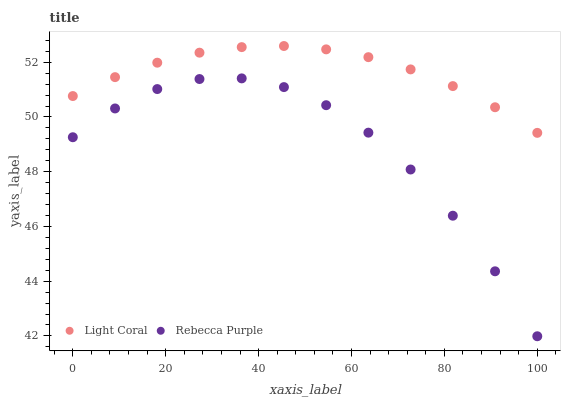Does Rebecca Purple have the minimum area under the curve?
Answer yes or no. Yes. Does Light Coral have the maximum area under the curve?
Answer yes or no. Yes. Does Rebecca Purple have the maximum area under the curve?
Answer yes or no. No. Is Light Coral the smoothest?
Answer yes or no. Yes. Is Rebecca Purple the roughest?
Answer yes or no. Yes. Is Rebecca Purple the smoothest?
Answer yes or no. No. Does Rebecca Purple have the lowest value?
Answer yes or no. Yes. Does Light Coral have the highest value?
Answer yes or no. Yes. Does Rebecca Purple have the highest value?
Answer yes or no. No. Is Rebecca Purple less than Light Coral?
Answer yes or no. Yes. Is Light Coral greater than Rebecca Purple?
Answer yes or no. Yes. Does Rebecca Purple intersect Light Coral?
Answer yes or no. No. 